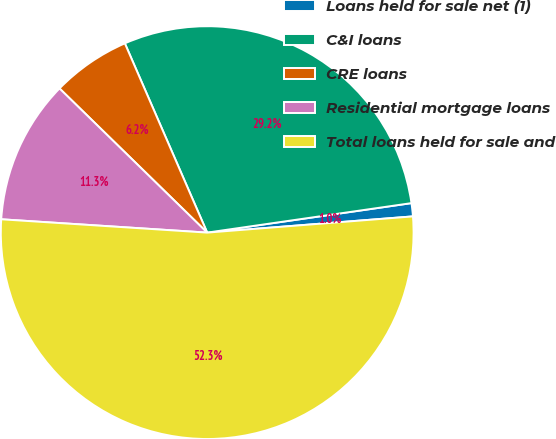Convert chart to OTSL. <chart><loc_0><loc_0><loc_500><loc_500><pie_chart><fcel>Loans held for sale net (1)<fcel>C&I loans<fcel>CRE loans<fcel>Residential mortgage loans<fcel>Total loans held for sale and<nl><fcel>1.03%<fcel>29.25%<fcel>6.16%<fcel>11.28%<fcel>52.28%<nl></chart> 